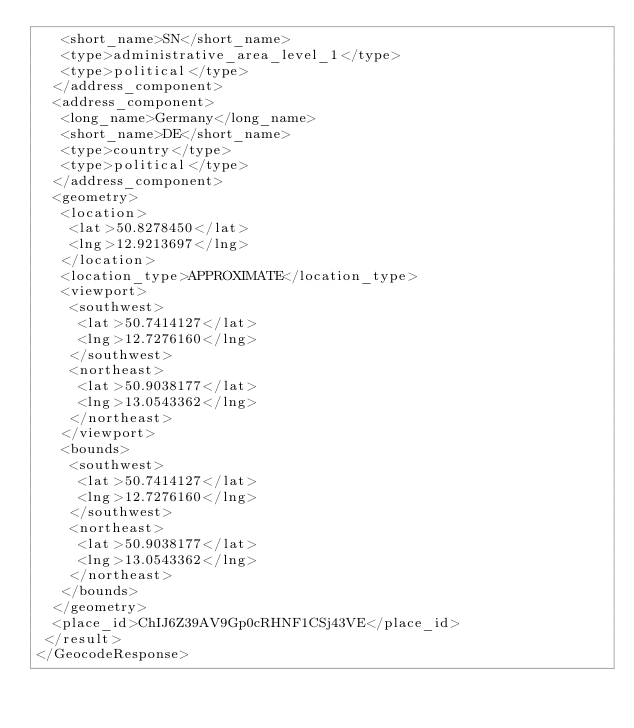<code> <loc_0><loc_0><loc_500><loc_500><_XML_>   <short_name>SN</short_name>
   <type>administrative_area_level_1</type>
   <type>political</type>
  </address_component>
  <address_component>
   <long_name>Germany</long_name>
   <short_name>DE</short_name>
   <type>country</type>
   <type>political</type>
  </address_component>
  <geometry>
   <location>
    <lat>50.8278450</lat>
    <lng>12.9213697</lng>
   </location>
   <location_type>APPROXIMATE</location_type>
   <viewport>
    <southwest>
     <lat>50.7414127</lat>
     <lng>12.7276160</lng>
    </southwest>
    <northeast>
     <lat>50.9038177</lat>
     <lng>13.0543362</lng>
    </northeast>
   </viewport>
   <bounds>
    <southwest>
     <lat>50.7414127</lat>
     <lng>12.7276160</lng>
    </southwest>
    <northeast>
     <lat>50.9038177</lat>
     <lng>13.0543362</lng>
    </northeast>
   </bounds>
  </geometry>
  <place_id>ChIJ6Z39AV9Gp0cRHNF1CSj43VE</place_id>
 </result>
</GeocodeResponse>
</code> 